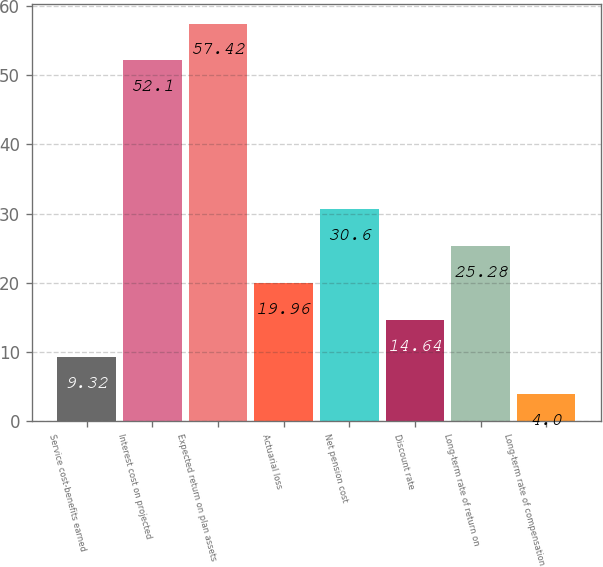Convert chart. <chart><loc_0><loc_0><loc_500><loc_500><bar_chart><fcel>Service cost-benefits earned<fcel>Interest cost on projected<fcel>Expected return on plan assets<fcel>Actuarial loss<fcel>Net pension cost<fcel>Discount rate<fcel>Long-term rate of return on<fcel>Long-term rate of compensation<nl><fcel>9.32<fcel>52.1<fcel>57.42<fcel>19.96<fcel>30.6<fcel>14.64<fcel>25.28<fcel>4<nl></chart> 